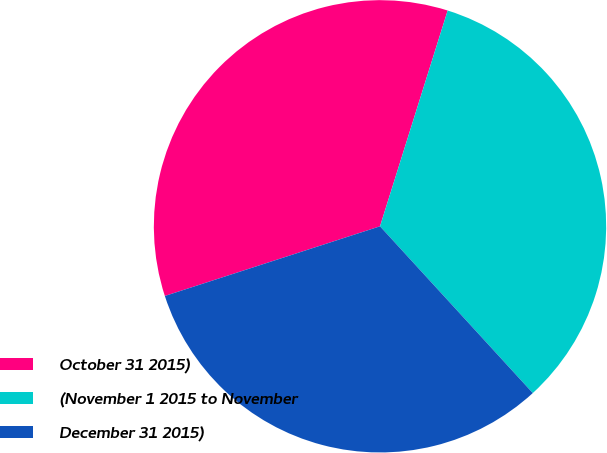<chart> <loc_0><loc_0><loc_500><loc_500><pie_chart><fcel>October 31 2015)<fcel>(November 1 2015 to November<fcel>December 31 2015)<nl><fcel>34.82%<fcel>33.36%<fcel>31.82%<nl></chart> 